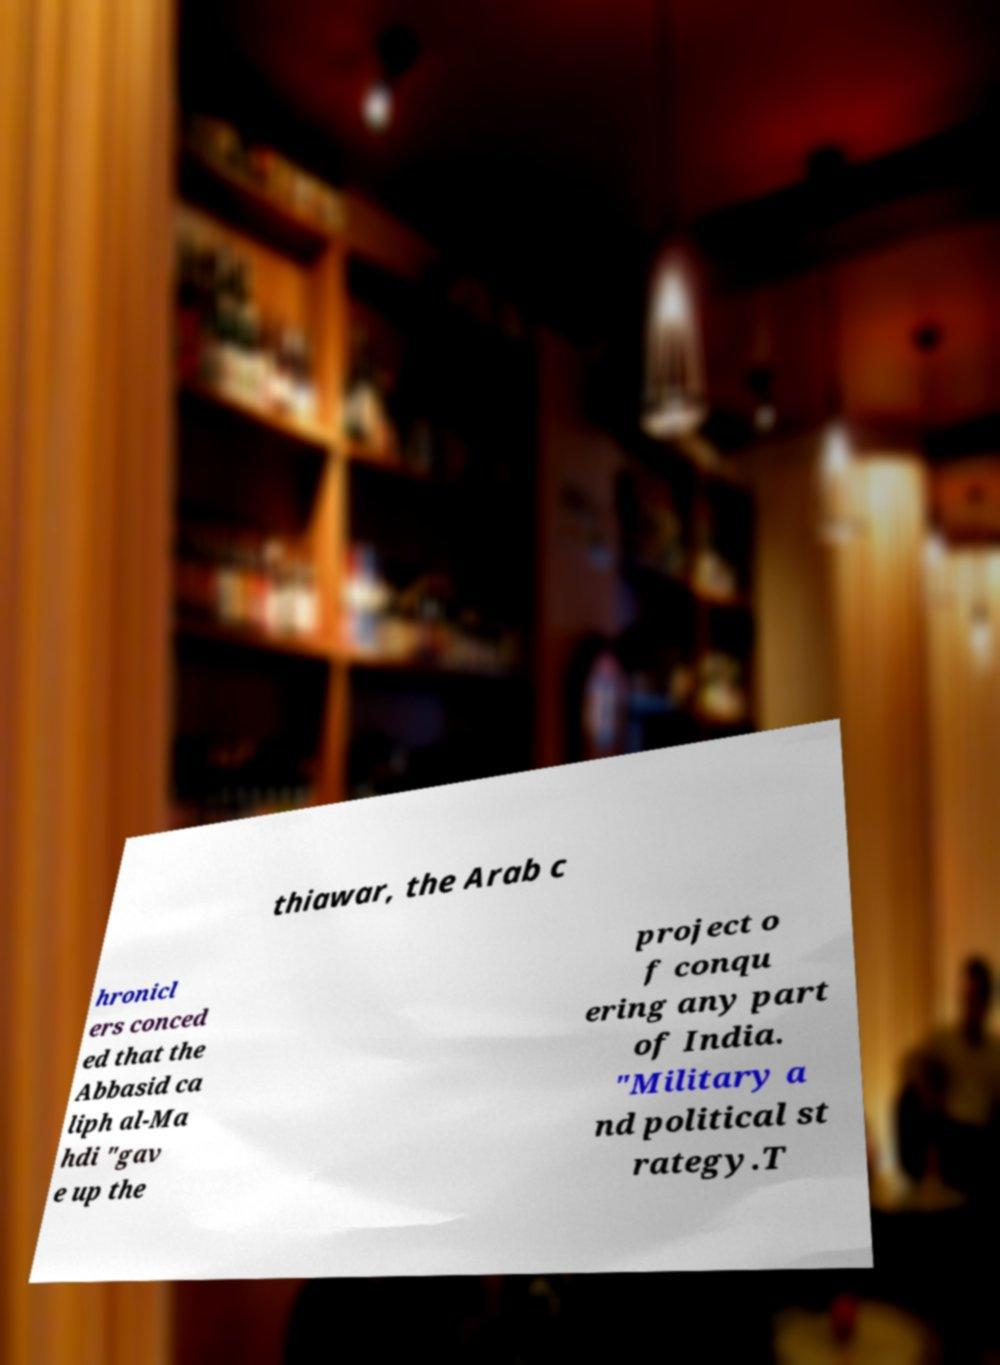What messages or text are displayed in this image? I need them in a readable, typed format. thiawar, the Arab c hronicl ers conced ed that the Abbasid ca liph al-Ma hdi "gav e up the project o f conqu ering any part of India. "Military a nd political st rategy.T 